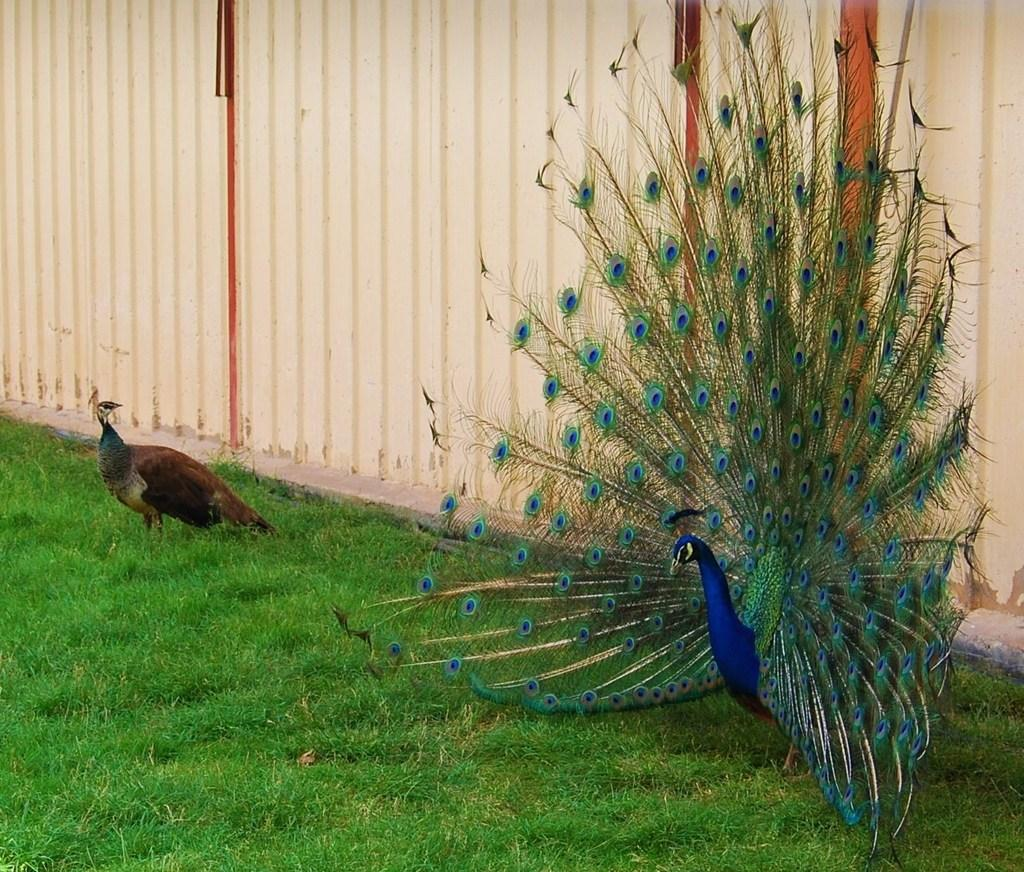What animal is on the ground in the image? There is a peacock on the ground in the image. What type of vegetation is on the ground in the image? There is grass on the ground in the image. What can be seen in the background of the image? There is a wall visible in the background of the image. Are there any other animals on the ground in the image? Yes, there is another bird on the ground to the left of the peacock in the image. What type of bone can be seen in the image? There is no bone present in the image. What type of cattle can be seen grazing in the grass in the image? There is no cattle present in the image; it only features a peacock and another bird. 